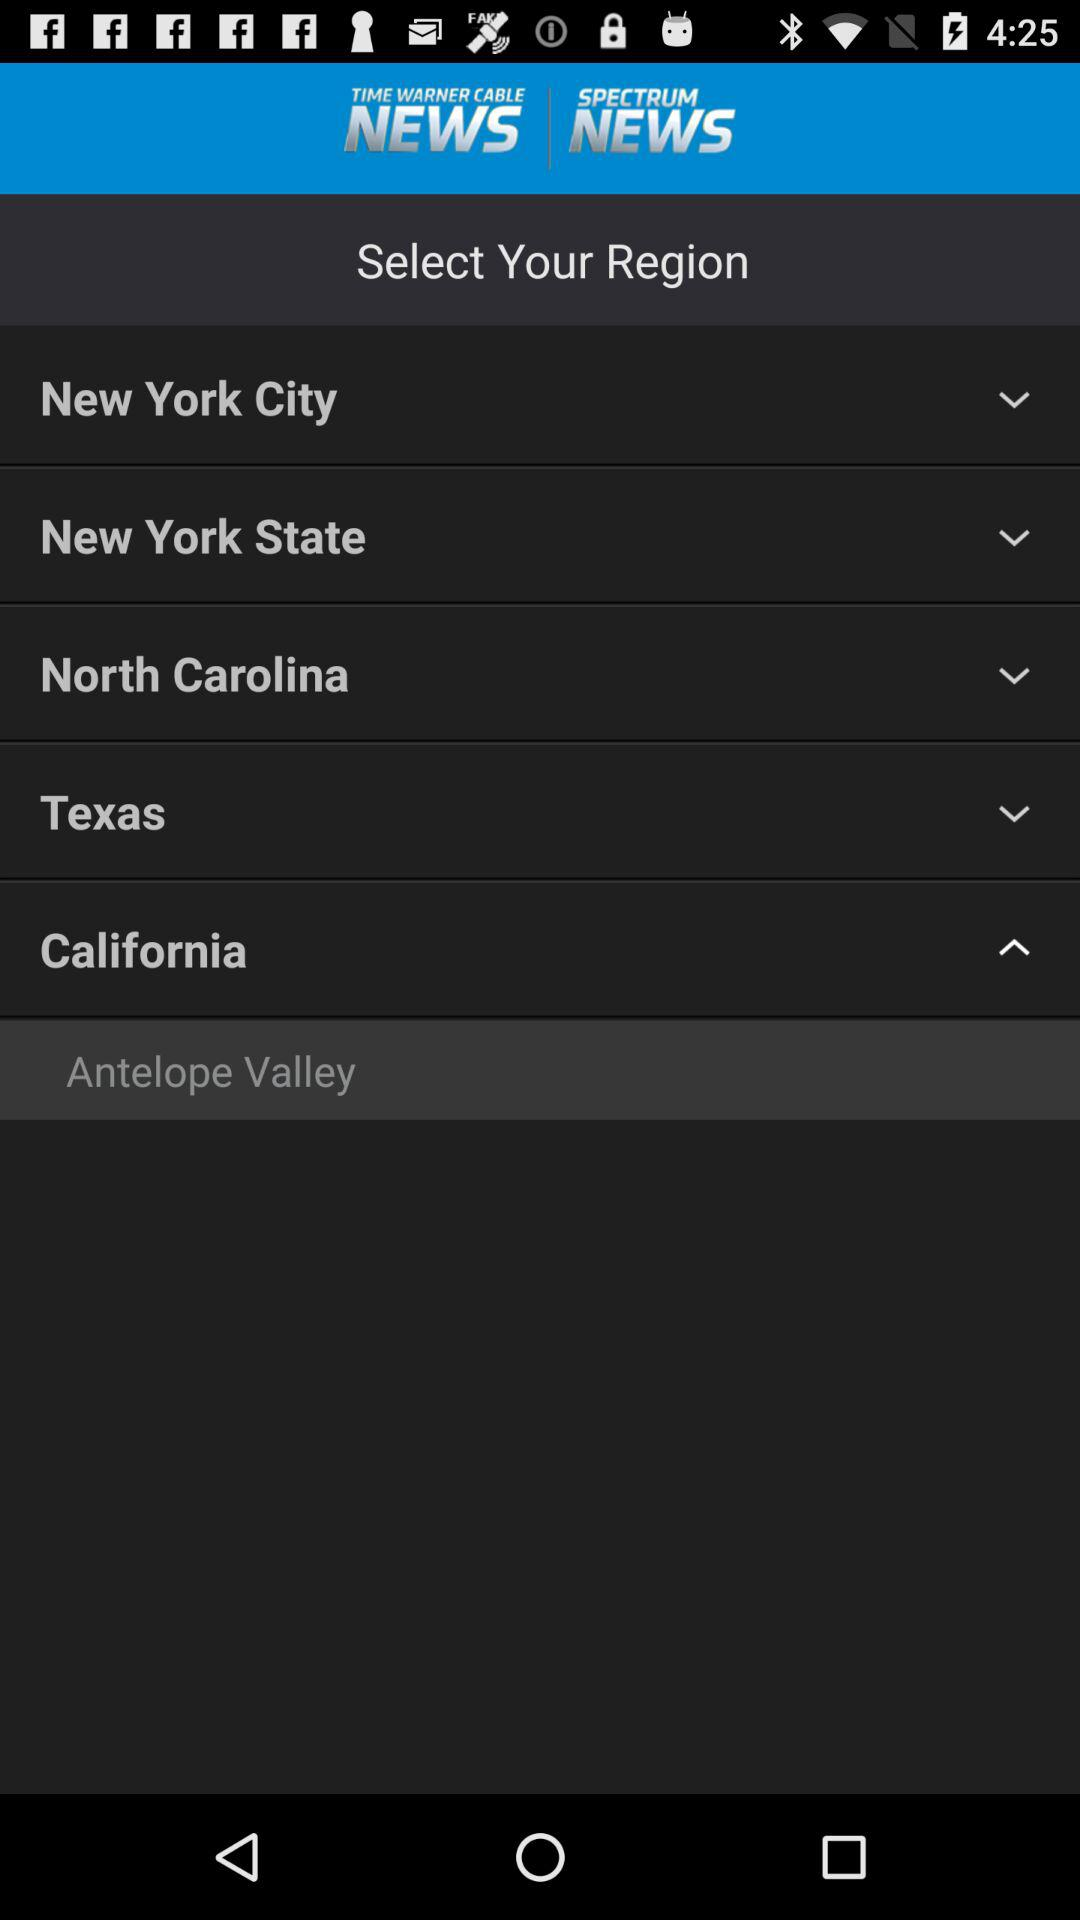What are the different available region options? The different available region options are "New York City", "New York State", "North Carolina", "Texas", "California" and "Antelope Valley". 